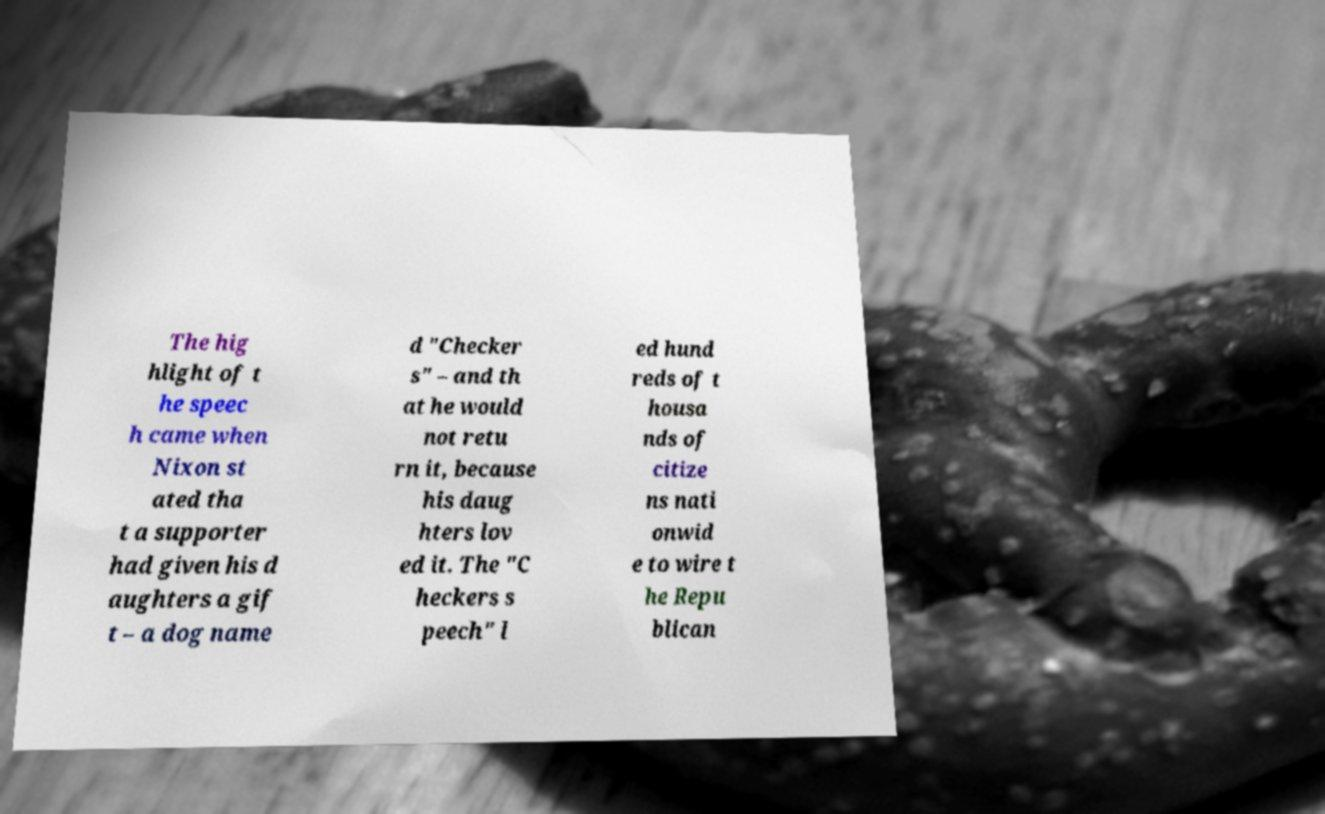Could you assist in decoding the text presented in this image and type it out clearly? The hig hlight of t he speec h came when Nixon st ated tha t a supporter had given his d aughters a gif t – a dog name d "Checker s" – and th at he would not retu rn it, because his daug hters lov ed it. The "C heckers s peech" l ed hund reds of t housa nds of citize ns nati onwid e to wire t he Repu blican 